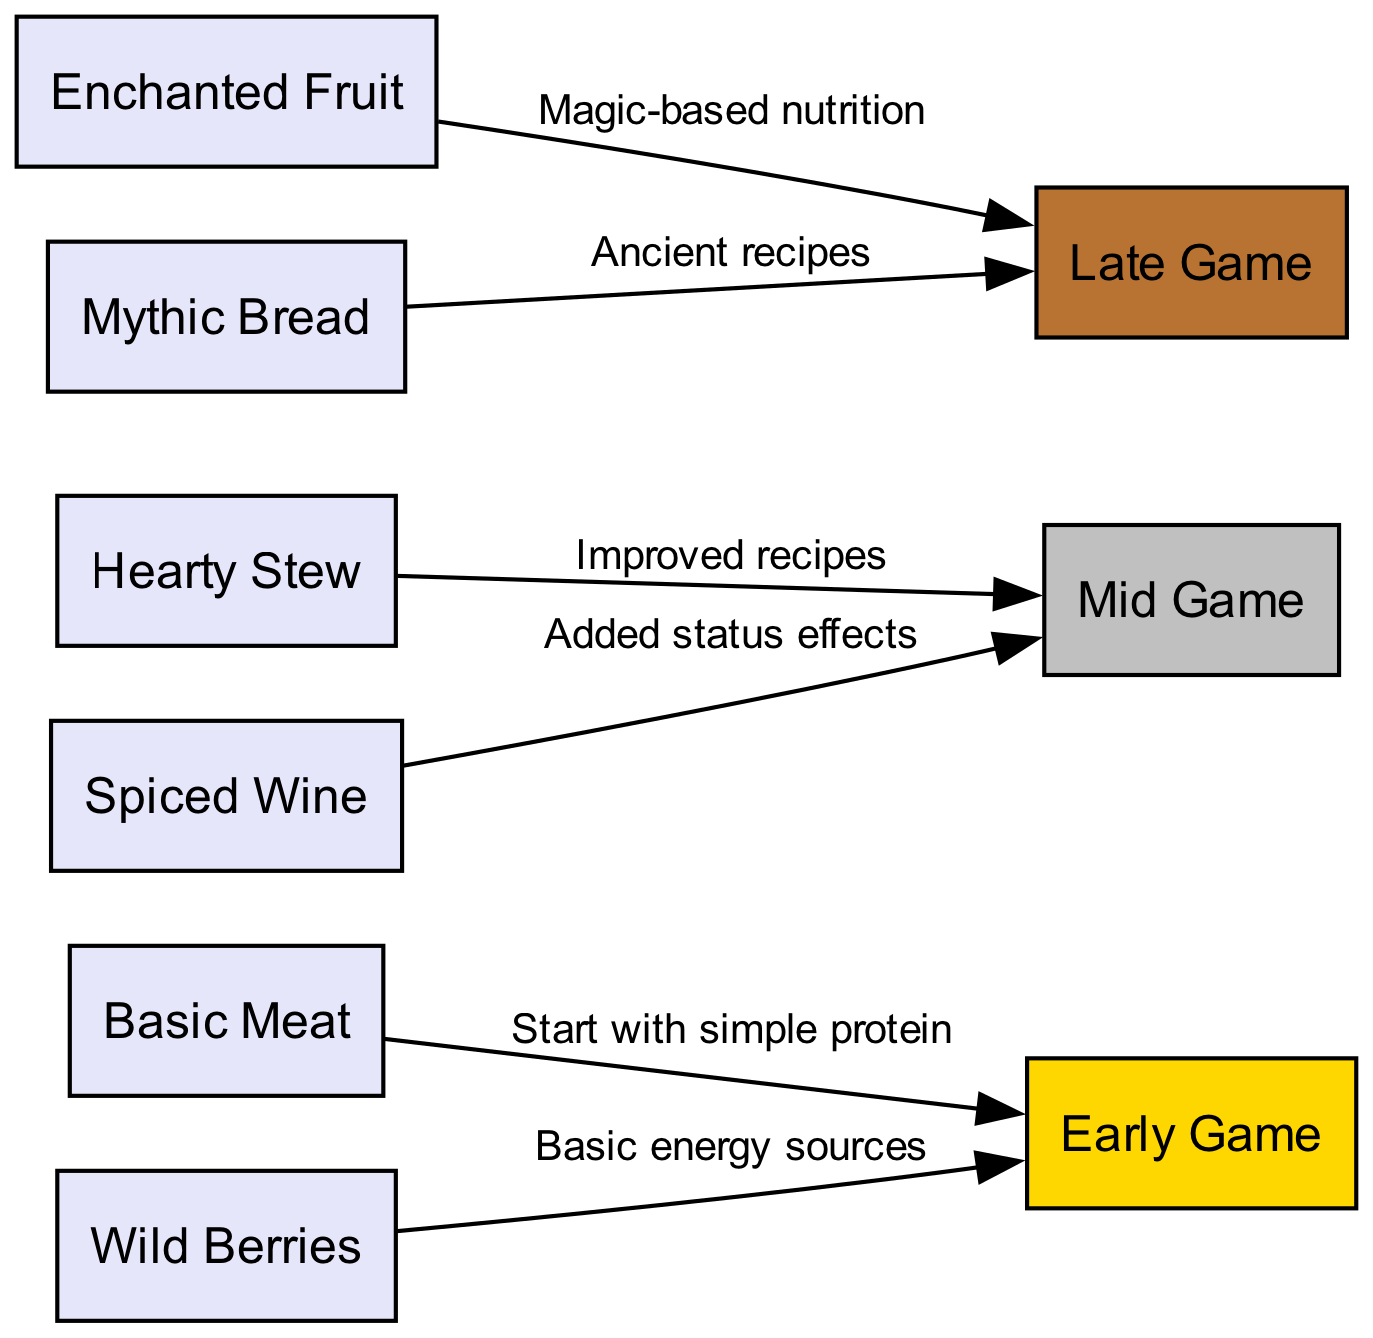What are the three main stages of the food chain? The diagram has three distinct nodes representing the game stages: Early Game, Mid Game, and Late Game. These nodes indicate the evolution of food sources through these stages.
Answer: Early Game, Mid Game, Late Game Which food item leads to the mid game? The edge from Hearty Stew points to the Mid Game node, indicating that this food item is significant for advancing to the mid-game stage.
Answer: Hearty Stew How many food items are listed in the early game? The nodes connected to the Early Game include Basic Meat and Wild Berries. Counting these gives a total of two food items in the early game stage.
Answer: 2 What effect do spiced wine provide compared to early game food items? The diagram states that Spiced Wine, connected to Mid Game, adds status effects, which is an enhancement over the basic energy sources provided by early game food items.
Answer: Added status effects What type of nutrition comes from enchanted fruit? Enchanted Fruit is connected to the Late Game node and is described as providing magic-based nutrition, indicating it is more advanced than earlier food items.
Answer: Magic-based nutrition What is the relationship between basic meat and the early game? Basic Meat is directly connected to the Early Game node, reflecting that it is one of the starting food sources for players at this stage.
Answer: Start with simple protein Which food item is associated with ancient recipes? The Late Game node connects to Mythic Bread, which is specifically described as being tied to ancient recipes, making it unique among food items.
Answer: Mythic Bread How many edges indicate a transition to the late game? There are two edges leading to the Late Game node: one from Enchanted Fruit and another from Mythic Bread, meaning there are two items indicating a transition to this stage.
Answer: 2 What is the first food item that players encounter? The Basic Meat node is connected to the Early Game node as the starting food source, signifying its primary introduction to players.
Answer: Basic Meat 